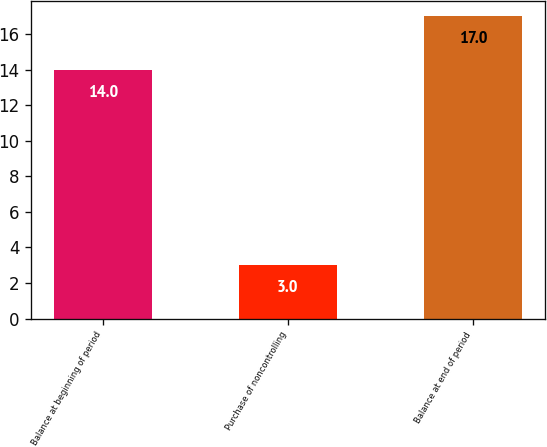<chart> <loc_0><loc_0><loc_500><loc_500><bar_chart><fcel>Balance at beginning of period<fcel>Purchase of noncontrolling<fcel>Balance at end of period<nl><fcel>14<fcel>3<fcel>17<nl></chart> 